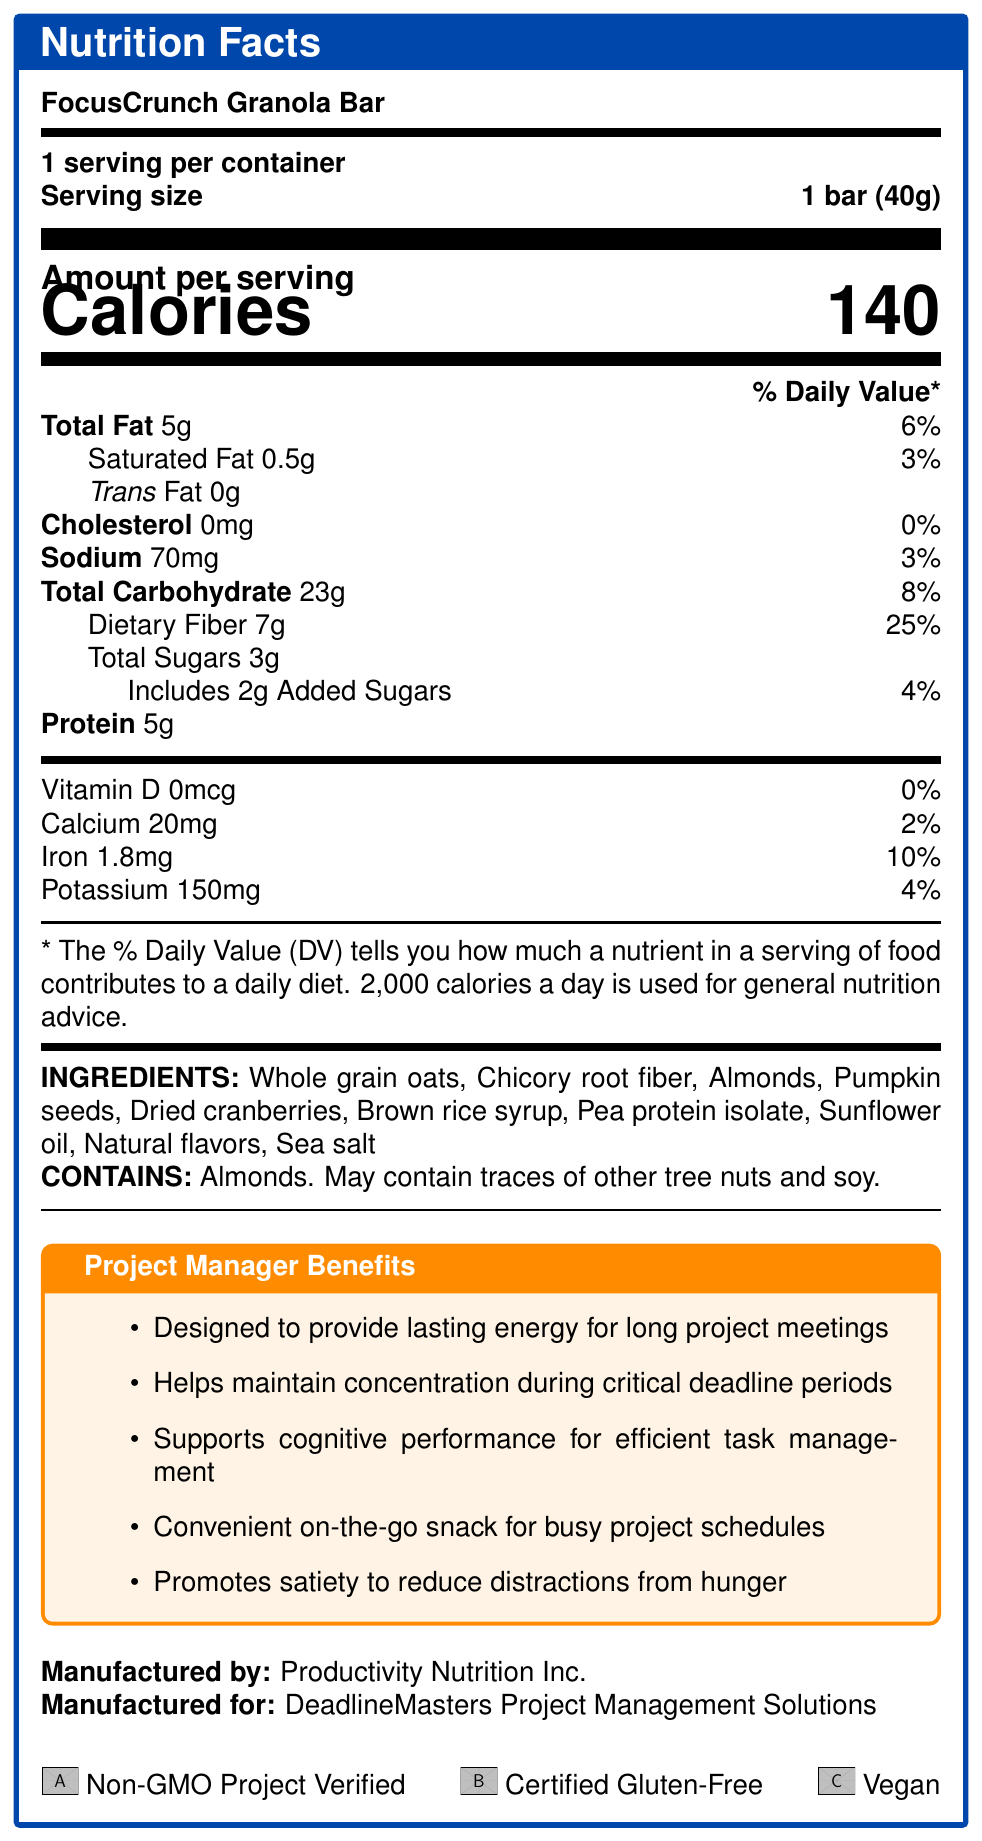How many servings are in one container of FocusCrunch Granola Bar? The document states that there are 6 servings per container.
Answer: 6 servings What is the dietary fiber content per serving? The dietary fiber content per serving is listed as 7g on the Nutrition Facts Label.
Answer: 7g List three ingredients found in the FocusCrunch Granola Bar. Three ingredients listed under the INGREDIENTS section are Whole grain oats, Almonds, and Dried cranberries.
Answer: Whole grain oats, Almonds, Dried cranberries What percentage of the daily value is the iron content in each serving? The iron content per serving is shown as 10% of the daily value.
Answer: 10% Is the product vegan? The certifications section indicates that the product is certified as Vegan.
Answer: Yes How many milligrams of potassium are there in one serving? The Nutrition Facts state that there are 150mg of potassium per serving.
Answer: 150mg What is the amount of added sugars per serving? The document indicates there are 2g of added sugars per serving.
Answer: 2g Which company manufactures the FocusCrunch Granola Bar? This information is provided under the "Manufactured by" section of the label.
Answer: Productivity Nutrition Inc. What benefit does high fiber provide according to the Project Manager Benefits section? The benefits section notes that high fiber content is designed to provide lasting energy.
Answer: Sustained energy List one claim about the product mentioned in the Claims Bullet Points section. One of the claims is that the product is low in sugar to help maintain focus.
Answer: Low in sugar to maintain focus What is the total carbohydrate percentage of the daily value per serving? A. 6% B. 8% C. 10% D. 15% The total carbohydrate percentage of the daily value per serving is listed as 8%.
Answer: B. 8% Which of the following certifications does the FocusCrunch Granola Bar have? A. USDA Organic B. Non-GMO Project Verified C. Fair Trade Certified D. Kosher The document lists Non-GMO Project Verified as one of the certifications.
Answer: B. Non-GMO Project Verified Does the product support cognitive performance? According to the Project Manager Benefits section, the product supports cognitive performance for efficient task management.
Answer: Yes Summarize the main idea of the document. The document provides detailed nutritional information, ingredients, allergen info, and specific benefits for project managers, emphasizing the snack's role in enhancing energy and focus during demanding projects.
Answer: The FocusCrunch Granola Bar is marketed as a nutritious, low-sugar, high-fiber snack designed to support sustained energy and concentration for project managers. It contains 140 calories per serving and is high in fiber and protein while being low in sugar. It has multiple health benefits and certifications, including being Non-GMO, Gluten-Free, and Vegan. What is the sodium content in a serving of FocusCrunch Granola Bar? The document specifies that each serving contains 70mg of sodium.
Answer: 70mg Which ingredient is not listed in the FocusCrunch Granola Bar? The question is asking for an ingredient that is not listed, but such information cannot be determined from the document without additional context.
Answer: I don't know 